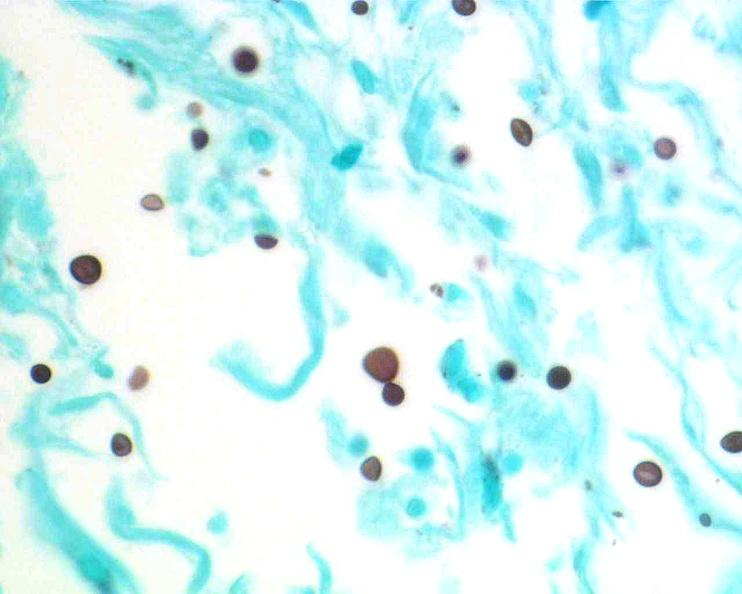what does this image show?
Answer the question using a single word or phrase. Brain 